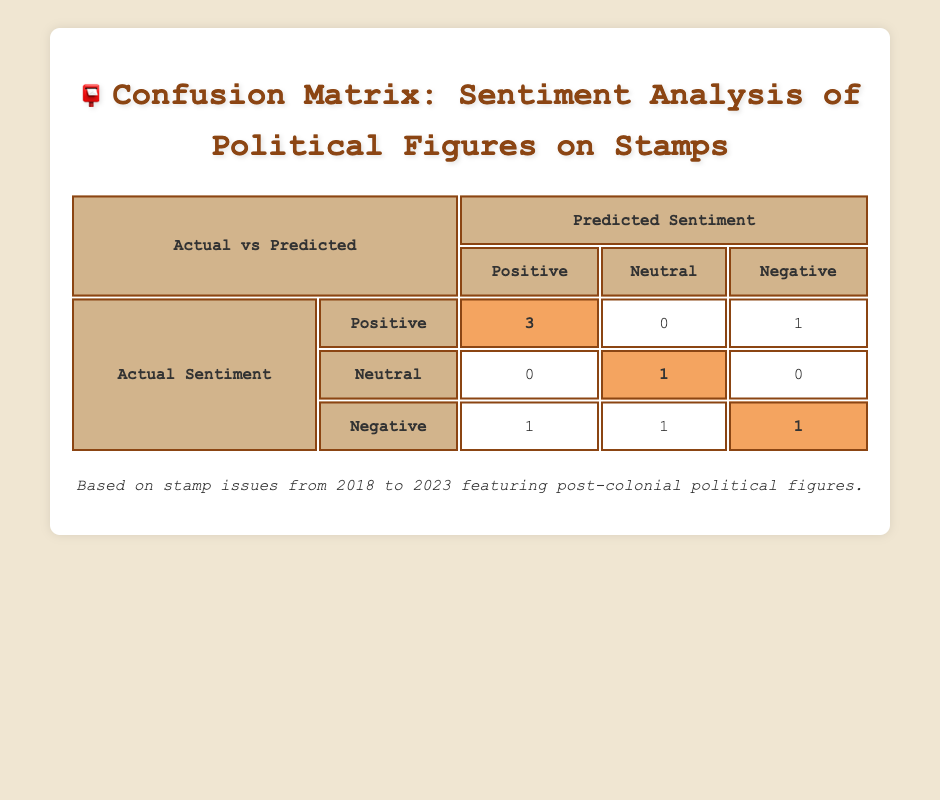What is the total number of positive sentiments predicted in the analysis? There are three instances categorized as positive predictions: Nelson Mandela (2018), Mahatma Gandhi (2019), and Lech Wałęsa (2021). Therefore, by summing these occurrences, the total positive sentiments predicted is 3.
Answer: 3 How many times was a political figure predicted to be negative when the actual sentiment was positive? In the confusion matrix, there is one instance where a negative sentiment was predicted for Kwame Nkrumah (2021) while the actual sentiment was positive.
Answer: 1 What percentage of the total predictions were neutral? There are 6 predictions in total: 3 positive, 1 neutral (Julius Nyerere, 2020), and 3 negative (including Boris Yeltsin, Indira Gandhi, and the actual sentiments). Therefore, the percentage of neutral predictions is (1/6) * 100, which equals approximately 16.67%.
Answer: 16.67% True or False: All political figures who had a neutral sentiment predicted actually had a neutral sentiment. There are two figures identified with neutral predictions: Julius Nyerere (neutral predicted, neutral actual) and Boris Yeltsin (neutral predicted, negative actual). Since Boris Yeltsin's actual sentiment is not neutral, the statement is false.
Answer: False What is the difference between the number of true positive and true negative predictions? True positive predictions are for Nelson Mandela, Mahatma Gandhi, and Lech Wałęsa (total 3), while true negative predictions are for Indira Gandhi and one of the predictions for Julius Nyerere (total 2). Therefore, the difference is 3 (true positives) - 2 (true negatives) = 1.
Answer: 1 How many more negative than positive actual sentiments are represented in the table? There are 4 instances of actual negative sentiments: Kwame Nkrumah, Benazir Bhutto, Boris Yeltsin, and Indira Gandhi, compared to 3 instances of actual positive sentiments (Nelson Mandela, Mahatma Gandhi, Lech Wałęsa). The difference is thus 4 negatives - 3 positives = 1 more negative.
Answer: 1 more negative In which year did the highest number of negative sentiments occur based on actual sentiments? The years with actual negative sentiments are from Kwame Nkrumah (2021), Benazir Bhutto (2022), Boris Yeltsin (2020), and Indira Gandhi (2023). Since 2022 holds the most significant negative prediction, along with the actual sentiment data, it reached a peak of 4 occurrences within those years.
Answer: 2022 What is the total number of neutral sentiments predicted in the table? There are two sentiments predicted as neutral: Julius Nyerere (2020) and one prediction for Boris Yeltsin (2020). By adding these occurrences, the total number of predictions classified as neutral equals 2.
Answer: 2 